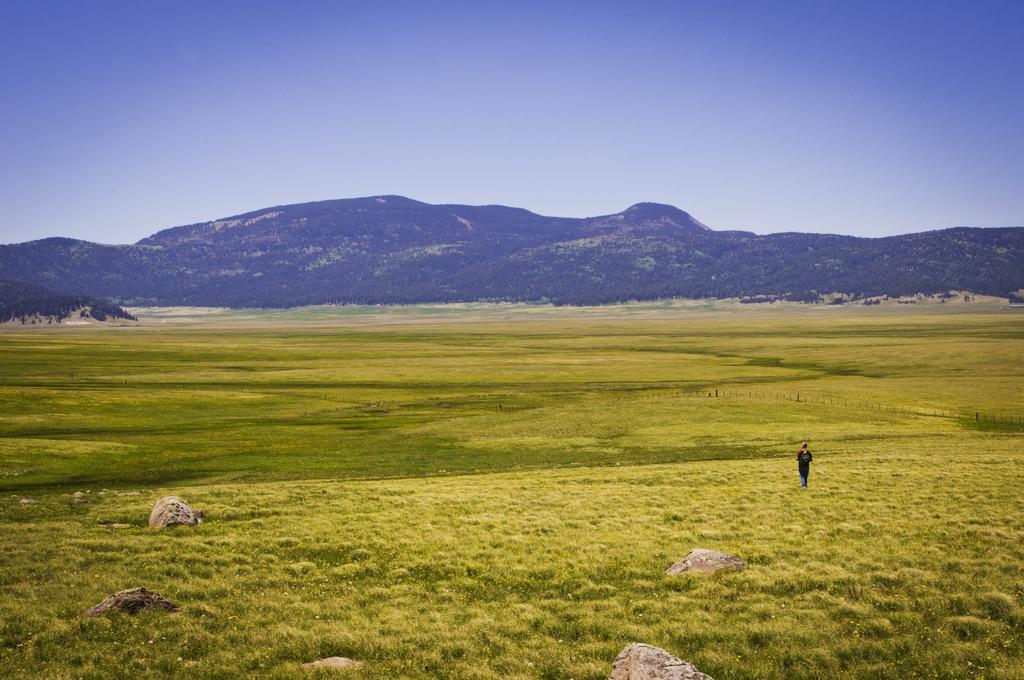What is the main subject of the image? There is a person standing in the image. Where is the person standing? The person is standing on the ground. What type of vegetation can be seen in the image? There is grass visible in the image. What can be seen in the distance in the image? There are mountains in the background of the image, and the sky is also visible. What type of screw can be seen holding the kettle in the image? There is no screw or kettle present in the image. What kind of pest is visible on the person's shoulder in the image? There are no pests visible on the person's shoulder in the image. 